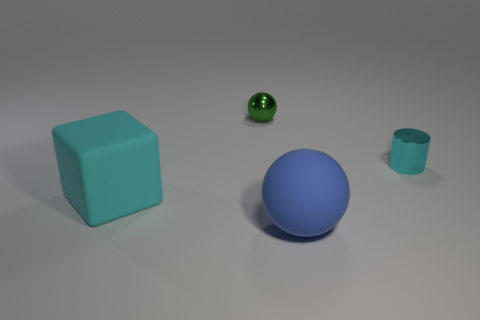What time of day does the lighting in the image suggest? The image depicts an indoor scene with no natural light or windows, so it's not really indicative of any particular time of day. The source of light seems artificial, casting soft shadows and providing even illumination to the objects. 